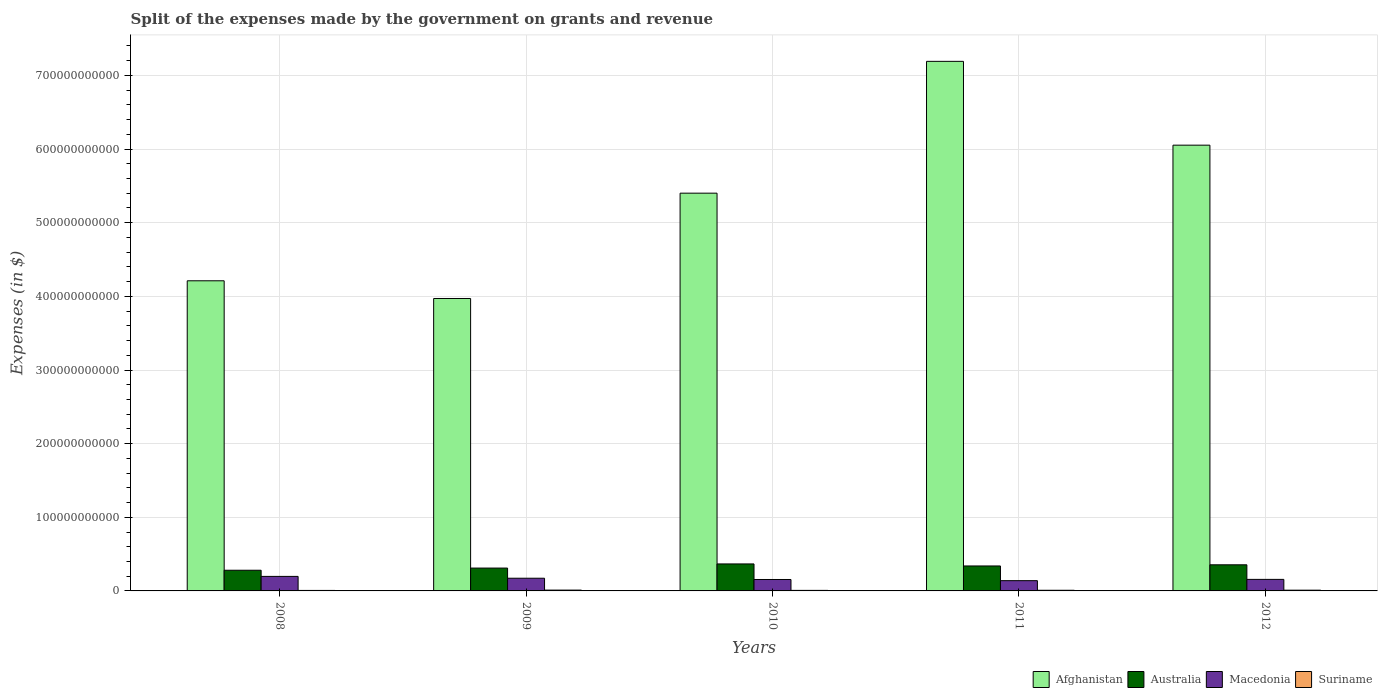How many groups of bars are there?
Give a very brief answer. 5. How many bars are there on the 4th tick from the left?
Give a very brief answer. 4. How many bars are there on the 1st tick from the right?
Your answer should be compact. 4. What is the label of the 3rd group of bars from the left?
Give a very brief answer. 2010. In how many cases, is the number of bars for a given year not equal to the number of legend labels?
Ensure brevity in your answer.  0. What is the expenses made by the government on grants and revenue in Suriname in 2009?
Give a very brief answer. 1.11e+09. Across all years, what is the maximum expenses made by the government on grants and revenue in Suriname?
Make the answer very short. 1.11e+09. Across all years, what is the minimum expenses made by the government on grants and revenue in Afghanistan?
Offer a terse response. 3.97e+11. In which year was the expenses made by the government on grants and revenue in Australia maximum?
Offer a very short reply. 2010. What is the total expenses made by the government on grants and revenue in Macedonia in the graph?
Offer a very short reply. 8.21e+1. What is the difference between the expenses made by the government on grants and revenue in Suriname in 2008 and that in 2012?
Offer a very short reply. -3.33e+08. What is the difference between the expenses made by the government on grants and revenue in Afghanistan in 2008 and the expenses made by the government on grants and revenue in Macedonia in 2012?
Keep it short and to the point. 4.05e+11. What is the average expenses made by the government on grants and revenue in Suriname per year?
Provide a succinct answer. 8.78e+08. In the year 2012, what is the difference between the expenses made by the government on grants and revenue in Suriname and expenses made by the government on grants and revenue in Macedonia?
Keep it short and to the point. -1.47e+1. What is the ratio of the expenses made by the government on grants and revenue in Afghanistan in 2008 to that in 2012?
Provide a succinct answer. 0.7. Is the difference between the expenses made by the government on grants and revenue in Suriname in 2009 and 2012 greater than the difference between the expenses made by the government on grants and revenue in Macedonia in 2009 and 2012?
Offer a very short reply. No. What is the difference between the highest and the second highest expenses made by the government on grants and revenue in Suriname?
Make the answer very short. 1.08e+08. What is the difference between the highest and the lowest expenses made by the government on grants and revenue in Suriname?
Give a very brief answer. 4.41e+08. What does the 3rd bar from the left in 2009 represents?
Your response must be concise. Macedonia. What does the 3rd bar from the right in 2012 represents?
Provide a short and direct response. Australia. Are all the bars in the graph horizontal?
Keep it short and to the point. No. How many years are there in the graph?
Your answer should be compact. 5. What is the difference between two consecutive major ticks on the Y-axis?
Make the answer very short. 1.00e+11. Are the values on the major ticks of Y-axis written in scientific E-notation?
Your response must be concise. No. Does the graph contain any zero values?
Offer a very short reply. No. Does the graph contain grids?
Your answer should be compact. Yes. How are the legend labels stacked?
Provide a succinct answer. Horizontal. What is the title of the graph?
Offer a terse response. Split of the expenses made by the government on grants and revenue. Does "Cuba" appear as one of the legend labels in the graph?
Your answer should be very brief. No. What is the label or title of the X-axis?
Offer a very short reply. Years. What is the label or title of the Y-axis?
Your response must be concise. Expenses (in $). What is the Expenses (in $) in Afghanistan in 2008?
Provide a short and direct response. 4.21e+11. What is the Expenses (in $) in Australia in 2008?
Provide a succinct answer. 2.81e+1. What is the Expenses (in $) of Macedonia in 2008?
Ensure brevity in your answer.  1.97e+1. What is the Expenses (in $) in Suriname in 2008?
Make the answer very short. 6.72e+08. What is the Expenses (in $) of Afghanistan in 2009?
Offer a very short reply. 3.97e+11. What is the Expenses (in $) in Australia in 2009?
Your answer should be very brief. 3.10e+1. What is the Expenses (in $) of Macedonia in 2009?
Provide a succinct answer. 1.72e+1. What is the Expenses (in $) of Suriname in 2009?
Make the answer very short. 1.11e+09. What is the Expenses (in $) in Afghanistan in 2010?
Provide a short and direct response. 5.40e+11. What is the Expenses (in $) in Australia in 2010?
Keep it short and to the point. 3.67e+1. What is the Expenses (in $) of Macedonia in 2010?
Your answer should be very brief. 1.55e+1. What is the Expenses (in $) of Suriname in 2010?
Keep it short and to the point. 7.28e+08. What is the Expenses (in $) of Afghanistan in 2011?
Offer a very short reply. 7.19e+11. What is the Expenses (in $) in Australia in 2011?
Give a very brief answer. 3.39e+1. What is the Expenses (in $) in Macedonia in 2011?
Give a very brief answer. 1.39e+1. What is the Expenses (in $) in Suriname in 2011?
Give a very brief answer. 8.71e+08. What is the Expenses (in $) of Afghanistan in 2012?
Your answer should be compact. 6.05e+11. What is the Expenses (in $) of Australia in 2012?
Make the answer very short. 3.55e+1. What is the Expenses (in $) in Macedonia in 2012?
Offer a very short reply. 1.57e+1. What is the Expenses (in $) in Suriname in 2012?
Your answer should be compact. 1.00e+09. Across all years, what is the maximum Expenses (in $) in Afghanistan?
Keep it short and to the point. 7.19e+11. Across all years, what is the maximum Expenses (in $) of Australia?
Give a very brief answer. 3.67e+1. Across all years, what is the maximum Expenses (in $) in Macedonia?
Offer a very short reply. 1.97e+1. Across all years, what is the maximum Expenses (in $) in Suriname?
Your answer should be compact. 1.11e+09. Across all years, what is the minimum Expenses (in $) in Afghanistan?
Make the answer very short. 3.97e+11. Across all years, what is the minimum Expenses (in $) of Australia?
Provide a short and direct response. 2.81e+1. Across all years, what is the minimum Expenses (in $) in Macedonia?
Provide a succinct answer. 1.39e+1. Across all years, what is the minimum Expenses (in $) of Suriname?
Provide a succinct answer. 6.72e+08. What is the total Expenses (in $) of Afghanistan in the graph?
Offer a very short reply. 2.68e+12. What is the total Expenses (in $) of Australia in the graph?
Your response must be concise. 1.65e+11. What is the total Expenses (in $) in Macedonia in the graph?
Your answer should be very brief. 8.21e+1. What is the total Expenses (in $) in Suriname in the graph?
Your answer should be very brief. 4.39e+09. What is the difference between the Expenses (in $) of Afghanistan in 2008 and that in 2009?
Your answer should be compact. 2.40e+1. What is the difference between the Expenses (in $) of Australia in 2008 and that in 2009?
Your answer should be compact. -2.93e+09. What is the difference between the Expenses (in $) in Macedonia in 2008 and that in 2009?
Make the answer very short. 2.49e+09. What is the difference between the Expenses (in $) in Suriname in 2008 and that in 2009?
Make the answer very short. -4.41e+08. What is the difference between the Expenses (in $) of Afghanistan in 2008 and that in 2010?
Make the answer very short. -1.19e+11. What is the difference between the Expenses (in $) of Australia in 2008 and that in 2010?
Keep it short and to the point. -8.56e+09. What is the difference between the Expenses (in $) in Macedonia in 2008 and that in 2010?
Your answer should be very brief. 4.20e+09. What is the difference between the Expenses (in $) in Suriname in 2008 and that in 2010?
Your response must be concise. -5.62e+07. What is the difference between the Expenses (in $) in Afghanistan in 2008 and that in 2011?
Your answer should be compact. -2.98e+11. What is the difference between the Expenses (in $) of Australia in 2008 and that in 2011?
Your answer should be compact. -5.81e+09. What is the difference between the Expenses (in $) of Macedonia in 2008 and that in 2011?
Offer a terse response. 5.80e+09. What is the difference between the Expenses (in $) of Suriname in 2008 and that in 2011?
Offer a terse response. -1.99e+08. What is the difference between the Expenses (in $) of Afghanistan in 2008 and that in 2012?
Your answer should be very brief. -1.84e+11. What is the difference between the Expenses (in $) in Australia in 2008 and that in 2012?
Offer a very short reply. -7.38e+09. What is the difference between the Expenses (in $) in Macedonia in 2008 and that in 2012?
Provide a succinct answer. 4.06e+09. What is the difference between the Expenses (in $) in Suriname in 2008 and that in 2012?
Your response must be concise. -3.33e+08. What is the difference between the Expenses (in $) in Afghanistan in 2009 and that in 2010?
Offer a very short reply. -1.43e+11. What is the difference between the Expenses (in $) of Australia in 2009 and that in 2010?
Provide a short and direct response. -5.63e+09. What is the difference between the Expenses (in $) of Macedonia in 2009 and that in 2010?
Provide a succinct answer. 1.71e+09. What is the difference between the Expenses (in $) of Suriname in 2009 and that in 2010?
Your answer should be compact. 3.84e+08. What is the difference between the Expenses (in $) in Afghanistan in 2009 and that in 2011?
Your answer should be compact. -3.22e+11. What is the difference between the Expenses (in $) in Australia in 2009 and that in 2011?
Offer a very short reply. -2.88e+09. What is the difference between the Expenses (in $) of Macedonia in 2009 and that in 2011?
Provide a succinct answer. 3.30e+09. What is the difference between the Expenses (in $) of Suriname in 2009 and that in 2011?
Provide a succinct answer. 2.42e+08. What is the difference between the Expenses (in $) of Afghanistan in 2009 and that in 2012?
Offer a terse response. -2.08e+11. What is the difference between the Expenses (in $) in Australia in 2009 and that in 2012?
Ensure brevity in your answer.  -4.45e+09. What is the difference between the Expenses (in $) of Macedonia in 2009 and that in 2012?
Your response must be concise. 1.56e+09. What is the difference between the Expenses (in $) in Suriname in 2009 and that in 2012?
Make the answer very short. 1.08e+08. What is the difference between the Expenses (in $) of Afghanistan in 2010 and that in 2011?
Your response must be concise. -1.79e+11. What is the difference between the Expenses (in $) of Australia in 2010 and that in 2011?
Your answer should be compact. 2.75e+09. What is the difference between the Expenses (in $) of Macedonia in 2010 and that in 2011?
Ensure brevity in your answer.  1.59e+09. What is the difference between the Expenses (in $) in Suriname in 2010 and that in 2011?
Your answer should be compact. -1.42e+08. What is the difference between the Expenses (in $) of Afghanistan in 2010 and that in 2012?
Give a very brief answer. -6.52e+1. What is the difference between the Expenses (in $) in Australia in 2010 and that in 2012?
Make the answer very short. 1.18e+09. What is the difference between the Expenses (in $) of Macedonia in 2010 and that in 2012?
Give a very brief answer. -1.47e+08. What is the difference between the Expenses (in $) of Suriname in 2010 and that in 2012?
Provide a succinct answer. -2.77e+08. What is the difference between the Expenses (in $) of Afghanistan in 2011 and that in 2012?
Ensure brevity in your answer.  1.14e+11. What is the difference between the Expenses (in $) of Australia in 2011 and that in 2012?
Offer a very short reply. -1.57e+09. What is the difference between the Expenses (in $) of Macedonia in 2011 and that in 2012?
Provide a succinct answer. -1.74e+09. What is the difference between the Expenses (in $) in Suriname in 2011 and that in 2012?
Provide a succinct answer. -1.34e+08. What is the difference between the Expenses (in $) of Afghanistan in 2008 and the Expenses (in $) of Australia in 2009?
Your response must be concise. 3.90e+11. What is the difference between the Expenses (in $) of Afghanistan in 2008 and the Expenses (in $) of Macedonia in 2009?
Give a very brief answer. 4.04e+11. What is the difference between the Expenses (in $) in Afghanistan in 2008 and the Expenses (in $) in Suriname in 2009?
Your response must be concise. 4.20e+11. What is the difference between the Expenses (in $) of Australia in 2008 and the Expenses (in $) of Macedonia in 2009?
Keep it short and to the point. 1.09e+1. What is the difference between the Expenses (in $) of Australia in 2008 and the Expenses (in $) of Suriname in 2009?
Make the answer very short. 2.70e+1. What is the difference between the Expenses (in $) of Macedonia in 2008 and the Expenses (in $) of Suriname in 2009?
Offer a terse response. 1.86e+1. What is the difference between the Expenses (in $) of Afghanistan in 2008 and the Expenses (in $) of Australia in 2010?
Your answer should be compact. 3.85e+11. What is the difference between the Expenses (in $) in Afghanistan in 2008 and the Expenses (in $) in Macedonia in 2010?
Offer a terse response. 4.06e+11. What is the difference between the Expenses (in $) of Afghanistan in 2008 and the Expenses (in $) of Suriname in 2010?
Give a very brief answer. 4.20e+11. What is the difference between the Expenses (in $) in Australia in 2008 and the Expenses (in $) in Macedonia in 2010?
Your answer should be very brief. 1.26e+1. What is the difference between the Expenses (in $) in Australia in 2008 and the Expenses (in $) in Suriname in 2010?
Your response must be concise. 2.74e+1. What is the difference between the Expenses (in $) in Macedonia in 2008 and the Expenses (in $) in Suriname in 2010?
Give a very brief answer. 1.90e+1. What is the difference between the Expenses (in $) of Afghanistan in 2008 and the Expenses (in $) of Australia in 2011?
Provide a short and direct response. 3.87e+11. What is the difference between the Expenses (in $) in Afghanistan in 2008 and the Expenses (in $) in Macedonia in 2011?
Ensure brevity in your answer.  4.07e+11. What is the difference between the Expenses (in $) of Afghanistan in 2008 and the Expenses (in $) of Suriname in 2011?
Offer a very short reply. 4.20e+11. What is the difference between the Expenses (in $) of Australia in 2008 and the Expenses (in $) of Macedonia in 2011?
Provide a succinct answer. 1.42e+1. What is the difference between the Expenses (in $) of Australia in 2008 and the Expenses (in $) of Suriname in 2011?
Ensure brevity in your answer.  2.72e+1. What is the difference between the Expenses (in $) of Macedonia in 2008 and the Expenses (in $) of Suriname in 2011?
Give a very brief answer. 1.89e+1. What is the difference between the Expenses (in $) of Afghanistan in 2008 and the Expenses (in $) of Australia in 2012?
Offer a terse response. 3.86e+11. What is the difference between the Expenses (in $) of Afghanistan in 2008 and the Expenses (in $) of Macedonia in 2012?
Your response must be concise. 4.05e+11. What is the difference between the Expenses (in $) in Afghanistan in 2008 and the Expenses (in $) in Suriname in 2012?
Ensure brevity in your answer.  4.20e+11. What is the difference between the Expenses (in $) of Australia in 2008 and the Expenses (in $) of Macedonia in 2012?
Make the answer very short. 1.24e+1. What is the difference between the Expenses (in $) in Australia in 2008 and the Expenses (in $) in Suriname in 2012?
Make the answer very short. 2.71e+1. What is the difference between the Expenses (in $) of Macedonia in 2008 and the Expenses (in $) of Suriname in 2012?
Offer a terse response. 1.87e+1. What is the difference between the Expenses (in $) of Afghanistan in 2009 and the Expenses (in $) of Australia in 2010?
Provide a succinct answer. 3.60e+11. What is the difference between the Expenses (in $) of Afghanistan in 2009 and the Expenses (in $) of Macedonia in 2010?
Make the answer very short. 3.82e+11. What is the difference between the Expenses (in $) of Afghanistan in 2009 and the Expenses (in $) of Suriname in 2010?
Your response must be concise. 3.96e+11. What is the difference between the Expenses (in $) of Australia in 2009 and the Expenses (in $) of Macedonia in 2010?
Make the answer very short. 1.55e+1. What is the difference between the Expenses (in $) in Australia in 2009 and the Expenses (in $) in Suriname in 2010?
Give a very brief answer. 3.03e+1. What is the difference between the Expenses (in $) of Macedonia in 2009 and the Expenses (in $) of Suriname in 2010?
Your answer should be very brief. 1.65e+1. What is the difference between the Expenses (in $) in Afghanistan in 2009 and the Expenses (in $) in Australia in 2011?
Provide a succinct answer. 3.63e+11. What is the difference between the Expenses (in $) in Afghanistan in 2009 and the Expenses (in $) in Macedonia in 2011?
Keep it short and to the point. 3.83e+11. What is the difference between the Expenses (in $) of Afghanistan in 2009 and the Expenses (in $) of Suriname in 2011?
Give a very brief answer. 3.96e+11. What is the difference between the Expenses (in $) of Australia in 2009 and the Expenses (in $) of Macedonia in 2011?
Make the answer very short. 1.71e+1. What is the difference between the Expenses (in $) in Australia in 2009 and the Expenses (in $) in Suriname in 2011?
Ensure brevity in your answer.  3.02e+1. What is the difference between the Expenses (in $) in Macedonia in 2009 and the Expenses (in $) in Suriname in 2011?
Keep it short and to the point. 1.64e+1. What is the difference between the Expenses (in $) of Afghanistan in 2009 and the Expenses (in $) of Australia in 2012?
Keep it short and to the point. 3.62e+11. What is the difference between the Expenses (in $) in Afghanistan in 2009 and the Expenses (in $) in Macedonia in 2012?
Your answer should be very brief. 3.81e+11. What is the difference between the Expenses (in $) in Afghanistan in 2009 and the Expenses (in $) in Suriname in 2012?
Your answer should be very brief. 3.96e+11. What is the difference between the Expenses (in $) in Australia in 2009 and the Expenses (in $) in Macedonia in 2012?
Your answer should be very brief. 1.54e+1. What is the difference between the Expenses (in $) of Australia in 2009 and the Expenses (in $) of Suriname in 2012?
Your response must be concise. 3.00e+1. What is the difference between the Expenses (in $) of Macedonia in 2009 and the Expenses (in $) of Suriname in 2012?
Your response must be concise. 1.62e+1. What is the difference between the Expenses (in $) in Afghanistan in 2010 and the Expenses (in $) in Australia in 2011?
Your response must be concise. 5.06e+11. What is the difference between the Expenses (in $) of Afghanistan in 2010 and the Expenses (in $) of Macedonia in 2011?
Ensure brevity in your answer.  5.26e+11. What is the difference between the Expenses (in $) in Afghanistan in 2010 and the Expenses (in $) in Suriname in 2011?
Give a very brief answer. 5.39e+11. What is the difference between the Expenses (in $) of Australia in 2010 and the Expenses (in $) of Macedonia in 2011?
Keep it short and to the point. 2.27e+1. What is the difference between the Expenses (in $) of Australia in 2010 and the Expenses (in $) of Suriname in 2011?
Your answer should be very brief. 3.58e+1. What is the difference between the Expenses (in $) of Macedonia in 2010 and the Expenses (in $) of Suriname in 2011?
Your response must be concise. 1.47e+1. What is the difference between the Expenses (in $) in Afghanistan in 2010 and the Expenses (in $) in Australia in 2012?
Provide a short and direct response. 5.05e+11. What is the difference between the Expenses (in $) in Afghanistan in 2010 and the Expenses (in $) in Macedonia in 2012?
Offer a very short reply. 5.24e+11. What is the difference between the Expenses (in $) of Afghanistan in 2010 and the Expenses (in $) of Suriname in 2012?
Your answer should be very brief. 5.39e+11. What is the difference between the Expenses (in $) in Australia in 2010 and the Expenses (in $) in Macedonia in 2012?
Make the answer very short. 2.10e+1. What is the difference between the Expenses (in $) of Australia in 2010 and the Expenses (in $) of Suriname in 2012?
Ensure brevity in your answer.  3.56e+1. What is the difference between the Expenses (in $) of Macedonia in 2010 and the Expenses (in $) of Suriname in 2012?
Offer a terse response. 1.45e+1. What is the difference between the Expenses (in $) of Afghanistan in 2011 and the Expenses (in $) of Australia in 2012?
Your answer should be compact. 6.84e+11. What is the difference between the Expenses (in $) in Afghanistan in 2011 and the Expenses (in $) in Macedonia in 2012?
Your answer should be compact. 7.03e+11. What is the difference between the Expenses (in $) of Afghanistan in 2011 and the Expenses (in $) of Suriname in 2012?
Make the answer very short. 7.18e+11. What is the difference between the Expenses (in $) in Australia in 2011 and the Expenses (in $) in Macedonia in 2012?
Your answer should be compact. 1.82e+1. What is the difference between the Expenses (in $) in Australia in 2011 and the Expenses (in $) in Suriname in 2012?
Ensure brevity in your answer.  3.29e+1. What is the difference between the Expenses (in $) of Macedonia in 2011 and the Expenses (in $) of Suriname in 2012?
Offer a terse response. 1.29e+1. What is the average Expenses (in $) of Afghanistan per year?
Provide a short and direct response. 5.37e+11. What is the average Expenses (in $) in Australia per year?
Provide a succinct answer. 3.30e+1. What is the average Expenses (in $) of Macedonia per year?
Offer a terse response. 1.64e+1. What is the average Expenses (in $) in Suriname per year?
Give a very brief answer. 8.78e+08. In the year 2008, what is the difference between the Expenses (in $) of Afghanistan and Expenses (in $) of Australia?
Your response must be concise. 3.93e+11. In the year 2008, what is the difference between the Expenses (in $) of Afghanistan and Expenses (in $) of Macedonia?
Offer a very short reply. 4.01e+11. In the year 2008, what is the difference between the Expenses (in $) in Afghanistan and Expenses (in $) in Suriname?
Your answer should be very brief. 4.20e+11. In the year 2008, what is the difference between the Expenses (in $) in Australia and Expenses (in $) in Macedonia?
Your answer should be very brief. 8.36e+09. In the year 2008, what is the difference between the Expenses (in $) of Australia and Expenses (in $) of Suriname?
Make the answer very short. 2.74e+1. In the year 2008, what is the difference between the Expenses (in $) of Macedonia and Expenses (in $) of Suriname?
Ensure brevity in your answer.  1.91e+1. In the year 2009, what is the difference between the Expenses (in $) of Afghanistan and Expenses (in $) of Australia?
Offer a very short reply. 3.66e+11. In the year 2009, what is the difference between the Expenses (in $) of Afghanistan and Expenses (in $) of Macedonia?
Offer a terse response. 3.80e+11. In the year 2009, what is the difference between the Expenses (in $) in Afghanistan and Expenses (in $) in Suriname?
Provide a succinct answer. 3.96e+11. In the year 2009, what is the difference between the Expenses (in $) of Australia and Expenses (in $) of Macedonia?
Provide a succinct answer. 1.38e+1. In the year 2009, what is the difference between the Expenses (in $) of Australia and Expenses (in $) of Suriname?
Your answer should be very brief. 2.99e+1. In the year 2009, what is the difference between the Expenses (in $) of Macedonia and Expenses (in $) of Suriname?
Offer a very short reply. 1.61e+1. In the year 2010, what is the difference between the Expenses (in $) in Afghanistan and Expenses (in $) in Australia?
Provide a short and direct response. 5.03e+11. In the year 2010, what is the difference between the Expenses (in $) in Afghanistan and Expenses (in $) in Macedonia?
Give a very brief answer. 5.25e+11. In the year 2010, what is the difference between the Expenses (in $) in Afghanistan and Expenses (in $) in Suriname?
Ensure brevity in your answer.  5.39e+11. In the year 2010, what is the difference between the Expenses (in $) in Australia and Expenses (in $) in Macedonia?
Give a very brief answer. 2.11e+1. In the year 2010, what is the difference between the Expenses (in $) of Australia and Expenses (in $) of Suriname?
Give a very brief answer. 3.59e+1. In the year 2010, what is the difference between the Expenses (in $) of Macedonia and Expenses (in $) of Suriname?
Ensure brevity in your answer.  1.48e+1. In the year 2011, what is the difference between the Expenses (in $) of Afghanistan and Expenses (in $) of Australia?
Your response must be concise. 6.85e+11. In the year 2011, what is the difference between the Expenses (in $) in Afghanistan and Expenses (in $) in Macedonia?
Make the answer very short. 7.05e+11. In the year 2011, what is the difference between the Expenses (in $) in Afghanistan and Expenses (in $) in Suriname?
Offer a very short reply. 7.18e+11. In the year 2011, what is the difference between the Expenses (in $) of Australia and Expenses (in $) of Macedonia?
Your answer should be very brief. 2.00e+1. In the year 2011, what is the difference between the Expenses (in $) of Australia and Expenses (in $) of Suriname?
Your response must be concise. 3.30e+1. In the year 2011, what is the difference between the Expenses (in $) of Macedonia and Expenses (in $) of Suriname?
Your answer should be compact. 1.31e+1. In the year 2012, what is the difference between the Expenses (in $) of Afghanistan and Expenses (in $) of Australia?
Your response must be concise. 5.70e+11. In the year 2012, what is the difference between the Expenses (in $) in Afghanistan and Expenses (in $) in Macedonia?
Provide a succinct answer. 5.90e+11. In the year 2012, what is the difference between the Expenses (in $) in Afghanistan and Expenses (in $) in Suriname?
Provide a succinct answer. 6.04e+11. In the year 2012, what is the difference between the Expenses (in $) of Australia and Expenses (in $) of Macedonia?
Ensure brevity in your answer.  1.98e+1. In the year 2012, what is the difference between the Expenses (in $) in Australia and Expenses (in $) in Suriname?
Provide a short and direct response. 3.45e+1. In the year 2012, what is the difference between the Expenses (in $) of Macedonia and Expenses (in $) of Suriname?
Offer a very short reply. 1.47e+1. What is the ratio of the Expenses (in $) of Afghanistan in 2008 to that in 2009?
Keep it short and to the point. 1.06. What is the ratio of the Expenses (in $) of Australia in 2008 to that in 2009?
Your response must be concise. 0.91. What is the ratio of the Expenses (in $) of Macedonia in 2008 to that in 2009?
Your answer should be very brief. 1.14. What is the ratio of the Expenses (in $) in Suriname in 2008 to that in 2009?
Make the answer very short. 0.6. What is the ratio of the Expenses (in $) of Afghanistan in 2008 to that in 2010?
Make the answer very short. 0.78. What is the ratio of the Expenses (in $) in Australia in 2008 to that in 2010?
Your answer should be very brief. 0.77. What is the ratio of the Expenses (in $) in Macedonia in 2008 to that in 2010?
Provide a succinct answer. 1.27. What is the ratio of the Expenses (in $) of Suriname in 2008 to that in 2010?
Your answer should be compact. 0.92. What is the ratio of the Expenses (in $) of Afghanistan in 2008 to that in 2011?
Provide a succinct answer. 0.59. What is the ratio of the Expenses (in $) of Australia in 2008 to that in 2011?
Your answer should be compact. 0.83. What is the ratio of the Expenses (in $) of Macedonia in 2008 to that in 2011?
Give a very brief answer. 1.42. What is the ratio of the Expenses (in $) of Suriname in 2008 to that in 2011?
Keep it short and to the point. 0.77. What is the ratio of the Expenses (in $) of Afghanistan in 2008 to that in 2012?
Make the answer very short. 0.7. What is the ratio of the Expenses (in $) of Australia in 2008 to that in 2012?
Give a very brief answer. 0.79. What is the ratio of the Expenses (in $) in Macedonia in 2008 to that in 2012?
Your answer should be compact. 1.26. What is the ratio of the Expenses (in $) in Suriname in 2008 to that in 2012?
Keep it short and to the point. 0.67. What is the ratio of the Expenses (in $) of Afghanistan in 2009 to that in 2010?
Your answer should be very brief. 0.74. What is the ratio of the Expenses (in $) in Australia in 2009 to that in 2010?
Make the answer very short. 0.85. What is the ratio of the Expenses (in $) of Macedonia in 2009 to that in 2010?
Your answer should be very brief. 1.11. What is the ratio of the Expenses (in $) in Suriname in 2009 to that in 2010?
Provide a short and direct response. 1.53. What is the ratio of the Expenses (in $) in Afghanistan in 2009 to that in 2011?
Your answer should be compact. 0.55. What is the ratio of the Expenses (in $) of Australia in 2009 to that in 2011?
Give a very brief answer. 0.92. What is the ratio of the Expenses (in $) in Macedonia in 2009 to that in 2011?
Give a very brief answer. 1.24. What is the ratio of the Expenses (in $) of Suriname in 2009 to that in 2011?
Your answer should be compact. 1.28. What is the ratio of the Expenses (in $) in Afghanistan in 2009 to that in 2012?
Ensure brevity in your answer.  0.66. What is the ratio of the Expenses (in $) in Australia in 2009 to that in 2012?
Offer a very short reply. 0.87. What is the ratio of the Expenses (in $) of Macedonia in 2009 to that in 2012?
Offer a terse response. 1.1. What is the ratio of the Expenses (in $) in Suriname in 2009 to that in 2012?
Provide a succinct answer. 1.11. What is the ratio of the Expenses (in $) in Afghanistan in 2010 to that in 2011?
Give a very brief answer. 0.75. What is the ratio of the Expenses (in $) in Australia in 2010 to that in 2011?
Provide a succinct answer. 1.08. What is the ratio of the Expenses (in $) in Macedonia in 2010 to that in 2011?
Provide a succinct answer. 1.11. What is the ratio of the Expenses (in $) of Suriname in 2010 to that in 2011?
Give a very brief answer. 0.84. What is the ratio of the Expenses (in $) of Afghanistan in 2010 to that in 2012?
Make the answer very short. 0.89. What is the ratio of the Expenses (in $) in Macedonia in 2010 to that in 2012?
Ensure brevity in your answer.  0.99. What is the ratio of the Expenses (in $) in Suriname in 2010 to that in 2012?
Make the answer very short. 0.72. What is the ratio of the Expenses (in $) of Afghanistan in 2011 to that in 2012?
Offer a terse response. 1.19. What is the ratio of the Expenses (in $) of Australia in 2011 to that in 2012?
Provide a short and direct response. 0.96. What is the ratio of the Expenses (in $) of Macedonia in 2011 to that in 2012?
Ensure brevity in your answer.  0.89. What is the ratio of the Expenses (in $) in Suriname in 2011 to that in 2012?
Make the answer very short. 0.87. What is the difference between the highest and the second highest Expenses (in $) in Afghanistan?
Make the answer very short. 1.14e+11. What is the difference between the highest and the second highest Expenses (in $) of Australia?
Offer a terse response. 1.18e+09. What is the difference between the highest and the second highest Expenses (in $) in Macedonia?
Provide a succinct answer. 2.49e+09. What is the difference between the highest and the second highest Expenses (in $) of Suriname?
Make the answer very short. 1.08e+08. What is the difference between the highest and the lowest Expenses (in $) in Afghanistan?
Your response must be concise. 3.22e+11. What is the difference between the highest and the lowest Expenses (in $) of Australia?
Ensure brevity in your answer.  8.56e+09. What is the difference between the highest and the lowest Expenses (in $) in Macedonia?
Offer a terse response. 5.80e+09. What is the difference between the highest and the lowest Expenses (in $) in Suriname?
Your response must be concise. 4.41e+08. 